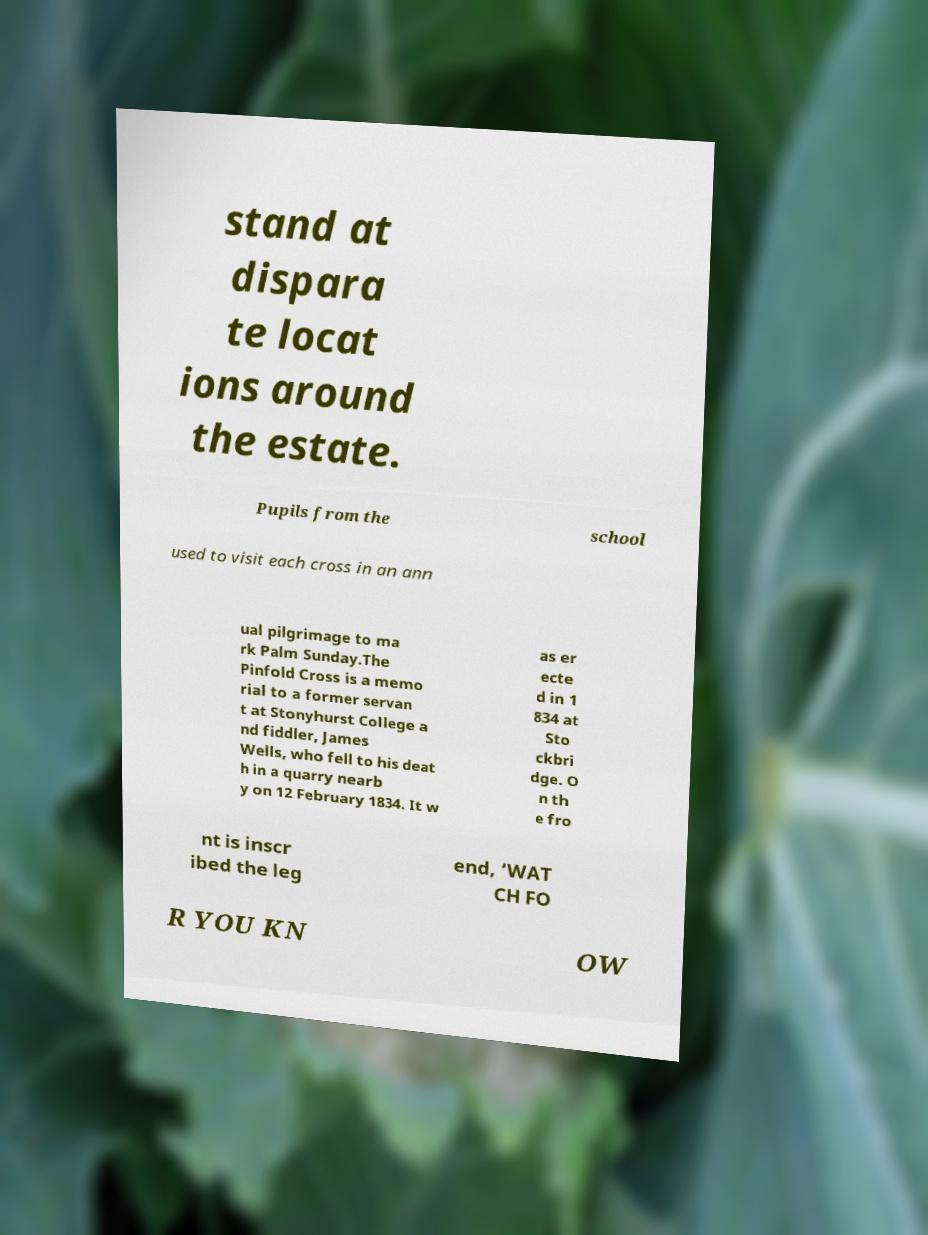Could you assist in decoding the text presented in this image and type it out clearly? stand at dispara te locat ions around the estate. Pupils from the school used to visit each cross in an ann ual pilgrimage to ma rk Palm Sunday.The Pinfold Cross is a memo rial to a former servan t at Stonyhurst College a nd fiddler, James Wells, who fell to his deat h in a quarry nearb y on 12 February 1834. It w as er ecte d in 1 834 at Sto ckbri dge. O n th e fro nt is inscr ibed the leg end, ‘WAT CH FO R YOU KN OW 